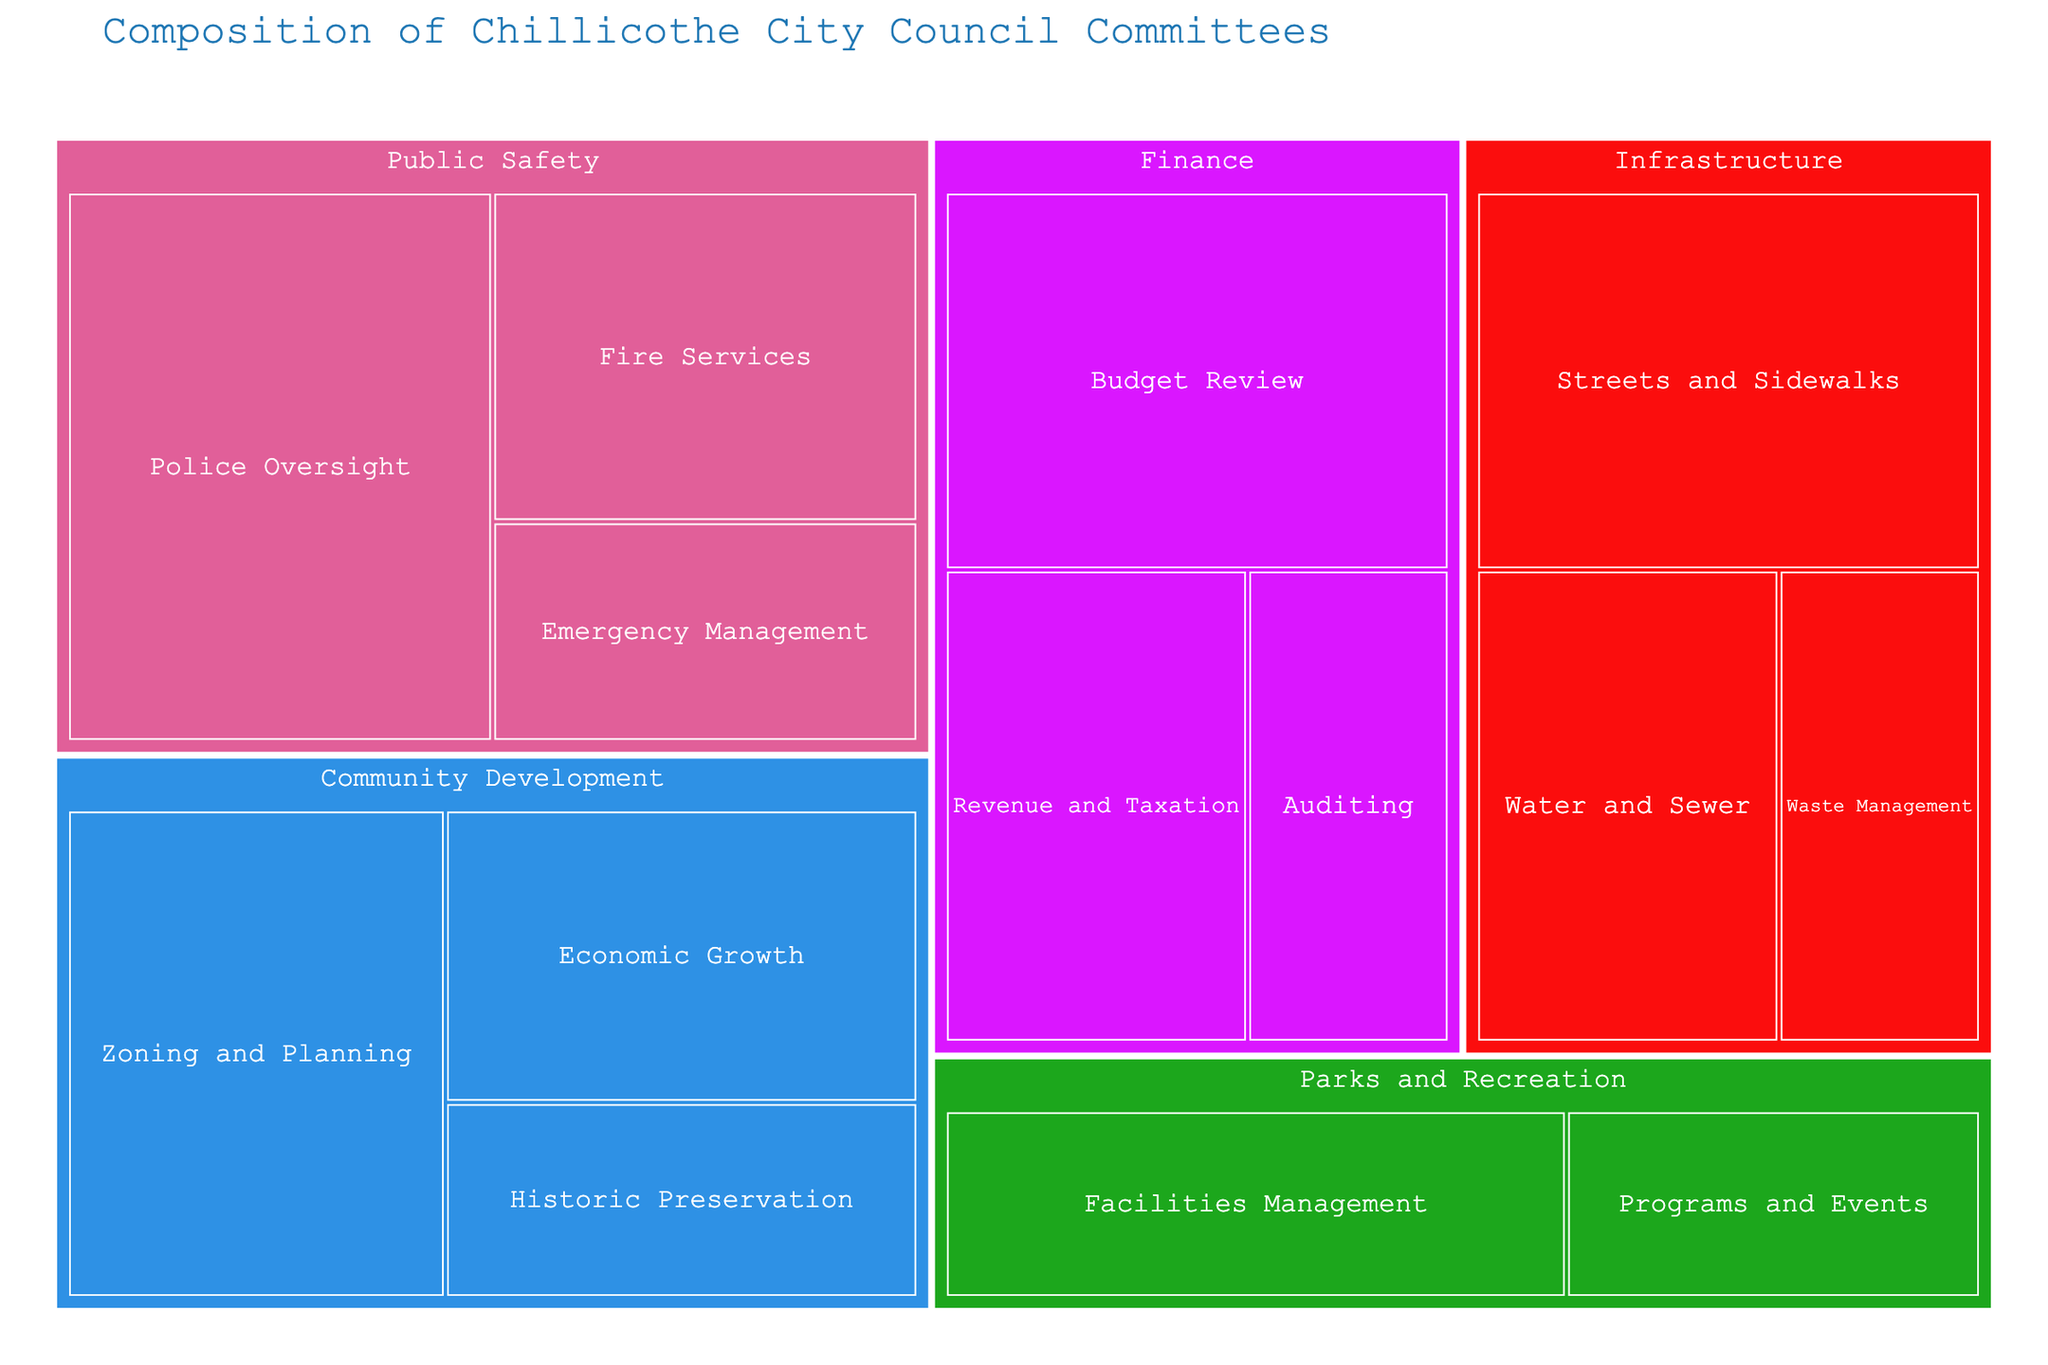How many members are in the Public Safety committee? The Public Safety committee is divided into three subcommittees: Police Oversight, Fire Services, and Emergency Management. Adding the members of each subcommittee (5 + 3 + 2) gives the total.
Answer: 10 Which subcommittee has the most members in the Finance committee? The subcommittees within the Finance committee are Budget Review (4 members), Revenue and Taxation (3 members), and Auditing (2 members). Comparing these numbers, Budget Review has the most members.
Answer: Budget Review What is the total number of members in the Infrastructure committee? The Infrastructure committee's members are divided among the Streets and Sidewalks (4 members), Water and Sewer (3 members), and Waste Management (2 members) subcommittees. Adding them together (4 + 3 + 2) gives the total.
Answer: 9 Which committee has the highest number of subcommittees? By scanning the treemap, the committees and the number of their subcommittees are: Public Safety (3), Finance (3), Community Development (3), Parks and Recreation (2), and Infrastructure (3). All except Parks and Recreation have the highest number of subcommittees, which is 3.
Answer: Public Safety, Finance, Community Development, Infrastructure How many subcommittees have exactly 3 members? From the treemap, the subcommittees with 3 members are Fire Services, Revenue and Taxation, Economic Growth, Facilities Management, and Water and Sewer. Counting these subcommittees gives a total of five.
Answer: 5 What percentage of the Community Development committee is composed of the Historic Preservation subcommittee? The Community Development committee has subcommittees with 4, 3, and 2 members respectively, summing to 9 members. The Historic Preservation subcommittee has 2 members. The percentage is (2/9) * 100.
Answer: ~22.22% Which committee is responsible for the most members overall? By adding the members in each committee: Public Safety (10), Finance (9), Community Development (9), Parks and Recreation (5), and Infrastructure (9). The Public Safety committee has the most members overall.
Answer: Public Safety Compare the size of the Programs and Events subcommittee to the Emergency Management subcommittee. Which is larger? From the treemap, Programs and Events has 2 members, and Emergency Management also has 2 members. Therefore, the sizes are equal.
Answer: They are equal Within the Parks and Recreation committee, which subcommittee has the smallest number of members? The subcommittees in the Parks and Recreation committee are Facilities Management (3 members) and Programs and Events (2 members). The smallest subcommittee is Programs and Events.
Answer: Programs and Events Is the number of members in the Streets and Sidewalks subcommittee more than or equal to the Zoning and Planning subcommittee? The Streets and Sidewalks subcommittee has 4 members and the Zoning and Planning subcommittee also has 4 members. Therefore, the numbers are equal.
Answer: Equal 